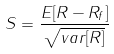Convert formula to latex. <formula><loc_0><loc_0><loc_500><loc_500>S = \frac { E [ R - R _ { f } ] } { \sqrt { v a r [ R ] } }</formula> 